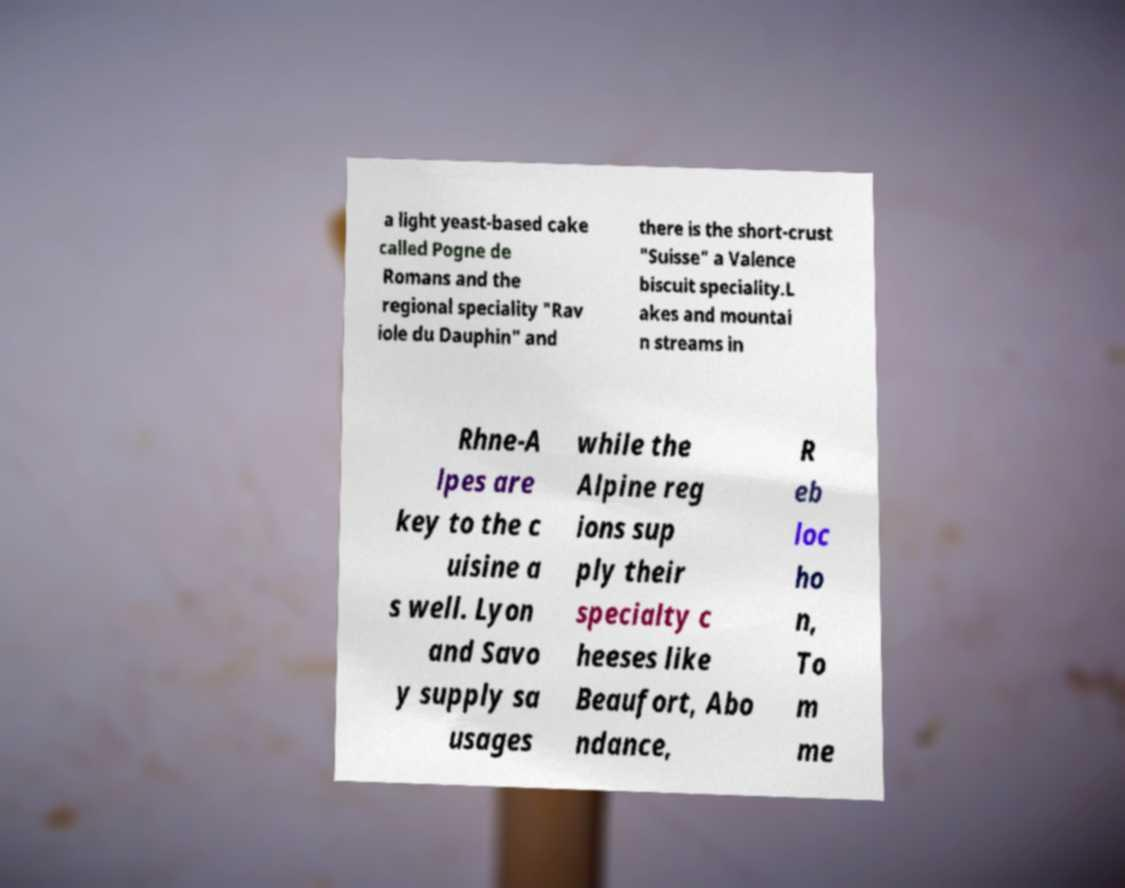Please identify and transcribe the text found in this image. a light yeast-based cake called Pogne de Romans and the regional speciality "Rav iole du Dauphin" and there is the short-crust "Suisse" a Valence biscuit speciality.L akes and mountai n streams in Rhne-A lpes are key to the c uisine a s well. Lyon and Savo y supply sa usages while the Alpine reg ions sup ply their specialty c heeses like Beaufort, Abo ndance, R eb loc ho n, To m me 